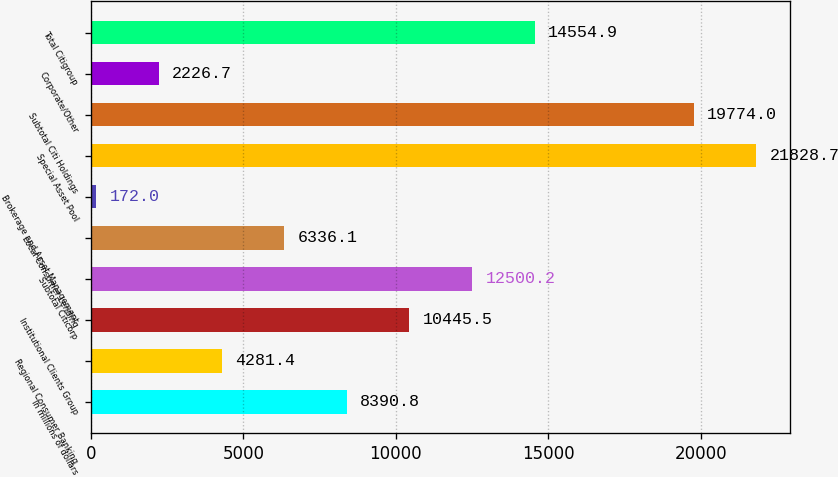Convert chart. <chart><loc_0><loc_0><loc_500><loc_500><bar_chart><fcel>In millions of dollars<fcel>Regional Consumer Banking<fcel>Institutional Clients Group<fcel>Subtotal Citicorp<fcel>Local Consumer Lending<fcel>Brokerage and Asset Management<fcel>Special Asset Pool<fcel>Subtotal Citi Holdings<fcel>Corporate/Other<fcel>Total Citigroup<nl><fcel>8390.8<fcel>4281.4<fcel>10445.5<fcel>12500.2<fcel>6336.1<fcel>172<fcel>21828.7<fcel>19774<fcel>2226.7<fcel>14554.9<nl></chart> 